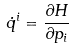<formula> <loc_0><loc_0><loc_500><loc_500>\dot { q } ^ { i } = \frac { \partial H } { \partial p _ { i } }</formula> 